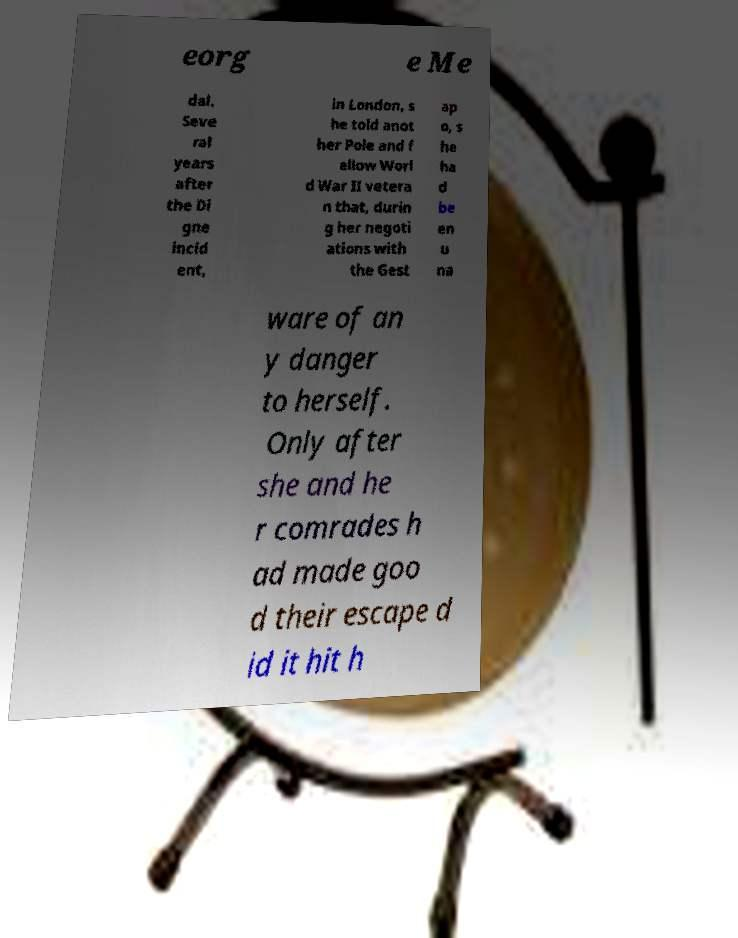Please read and relay the text visible in this image. What does it say? eorg e Me dal. Seve ral years after the Di gne incid ent, in London, s he told anot her Pole and f ellow Worl d War II vetera n that, durin g her negoti ations with the Gest ap o, s he ha d be en u na ware of an y danger to herself. Only after she and he r comrades h ad made goo d their escape d id it hit h 